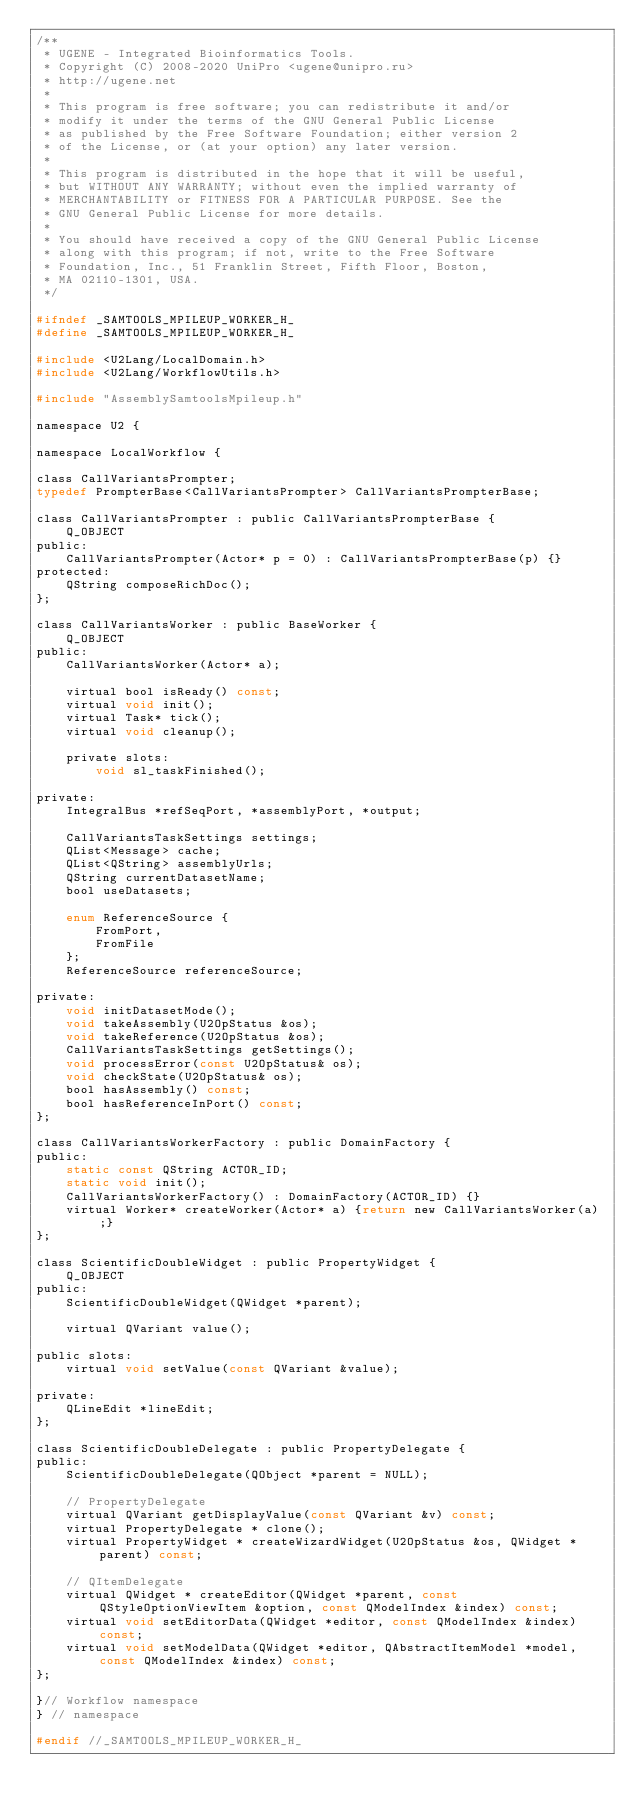<code> <loc_0><loc_0><loc_500><loc_500><_C_>/**
 * UGENE - Integrated Bioinformatics Tools.
 * Copyright (C) 2008-2020 UniPro <ugene@unipro.ru>
 * http://ugene.net
 *
 * This program is free software; you can redistribute it and/or
 * modify it under the terms of the GNU General Public License
 * as published by the Free Software Foundation; either version 2
 * of the License, or (at your option) any later version.
 *
 * This program is distributed in the hope that it will be useful,
 * but WITHOUT ANY WARRANTY; without even the implied warranty of
 * MERCHANTABILITY or FITNESS FOR A PARTICULAR PURPOSE. See the
 * GNU General Public License for more details.
 *
 * You should have received a copy of the GNU General Public License
 * along with this program; if not, write to the Free Software
 * Foundation, Inc., 51 Franklin Street, Fifth Floor, Boston,
 * MA 02110-1301, USA.
 */

#ifndef _SAMTOOLS_MPILEUP_WORKER_H_
#define _SAMTOOLS_MPILEUP_WORKER_H_

#include <U2Lang/LocalDomain.h>
#include <U2Lang/WorkflowUtils.h>

#include "AssemblySamtoolsMpileup.h"

namespace U2 {

namespace LocalWorkflow {

class CallVariantsPrompter;
typedef PrompterBase<CallVariantsPrompter> CallVariantsPrompterBase;

class CallVariantsPrompter : public CallVariantsPrompterBase {
    Q_OBJECT
public:
    CallVariantsPrompter(Actor* p = 0) : CallVariantsPrompterBase(p) {}
protected:
    QString composeRichDoc();
};

class CallVariantsWorker : public BaseWorker {
    Q_OBJECT
public:
    CallVariantsWorker(Actor* a);

    virtual bool isReady() const;
    virtual void init();
    virtual Task* tick();
    virtual void cleanup();

    private slots:
        void sl_taskFinished();

private:
    IntegralBus *refSeqPort, *assemblyPort, *output;

    CallVariantsTaskSettings settings;
    QList<Message> cache;
    QList<QString> assemblyUrls;
    QString currentDatasetName;
    bool useDatasets;

    enum ReferenceSource {
        FromPort,
        FromFile
    };
    ReferenceSource referenceSource;

private:
    void initDatasetMode();
    void takeAssembly(U2OpStatus &os);
    void takeReference(U2OpStatus &os);
    CallVariantsTaskSettings getSettings();
    void processError(const U2OpStatus& os);
    void checkState(U2OpStatus& os);
    bool hasAssembly() const;
    bool hasReferenceInPort() const;
};

class CallVariantsWorkerFactory : public DomainFactory {
public:
    static const QString ACTOR_ID;
    static void init();
    CallVariantsWorkerFactory() : DomainFactory(ACTOR_ID) {}
    virtual Worker* createWorker(Actor* a) {return new CallVariantsWorker(a);}
};

class ScientificDoubleWidget : public PropertyWidget {
    Q_OBJECT
public:
    ScientificDoubleWidget(QWidget *parent);

    virtual QVariant value();

public slots:
    virtual void setValue(const QVariant &value);

private:
    QLineEdit *lineEdit;
};

class ScientificDoubleDelegate : public PropertyDelegate {
public:
    ScientificDoubleDelegate(QObject *parent = NULL);

    // PropertyDelegate
    virtual QVariant getDisplayValue(const QVariant &v) const;
    virtual PropertyDelegate * clone();
    virtual PropertyWidget * createWizardWidget(U2OpStatus &os, QWidget *parent) const;

    // QItemDelegate
    virtual QWidget * createEditor(QWidget *parent, const QStyleOptionViewItem &option, const QModelIndex &index) const;
    virtual void setEditorData(QWidget *editor, const QModelIndex &index) const;
    virtual void setModelData(QWidget *editor, QAbstractItemModel *model, const QModelIndex &index) const;
};

}// Workflow namespace
} // namespace

#endif //_SAMTOOLS_MPILEUP_WORKER_H_
</code> 